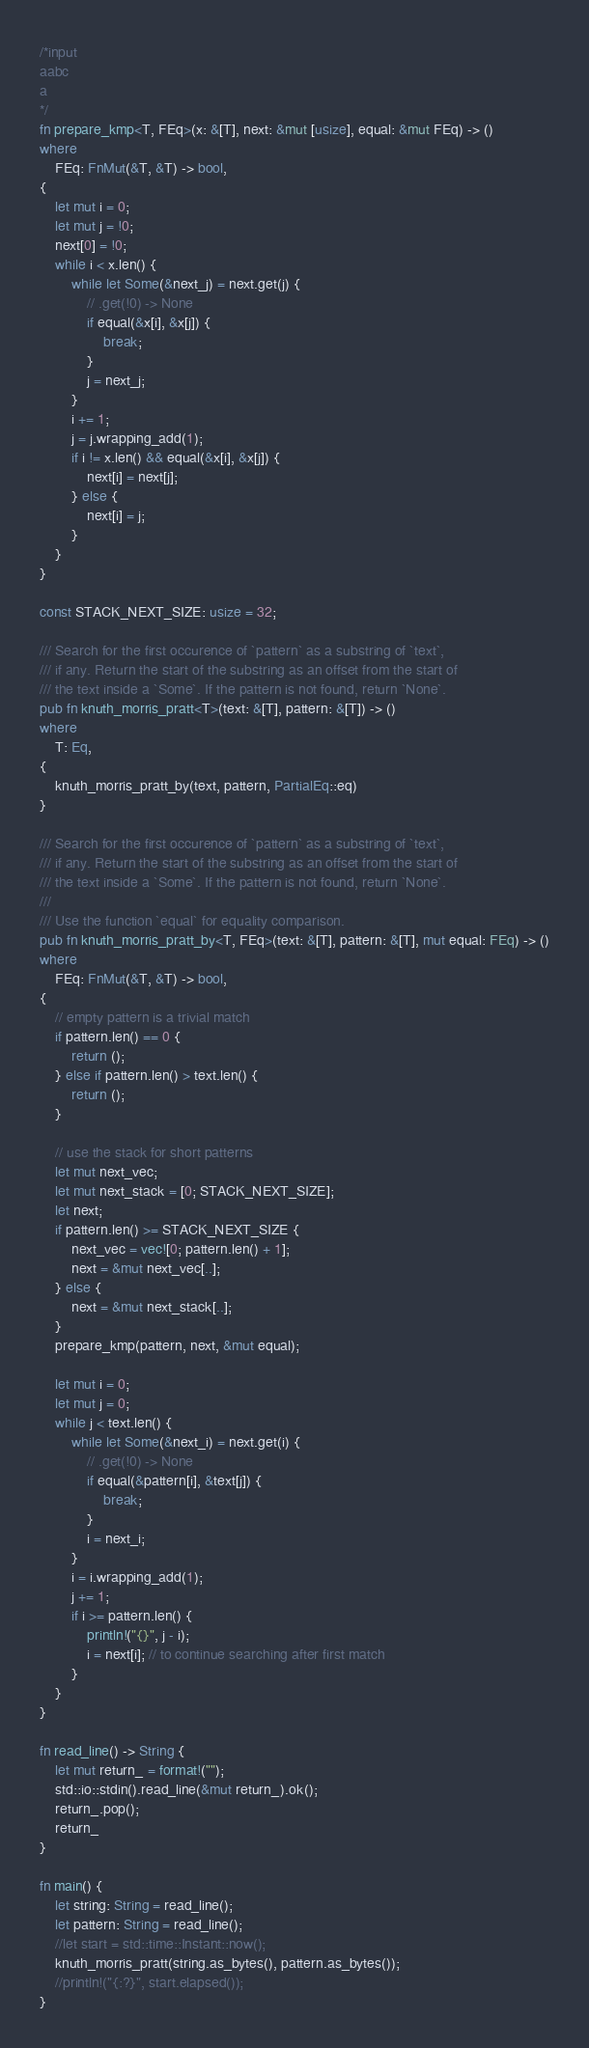Convert code to text. <code><loc_0><loc_0><loc_500><loc_500><_Rust_>/*input
aabc
a
*/
fn prepare_kmp<T, FEq>(x: &[T], next: &mut [usize], equal: &mut FEq) -> ()
where
    FEq: FnMut(&T, &T) -> bool,
{
    let mut i = 0;
    let mut j = !0;
    next[0] = !0;
    while i < x.len() {
        while let Some(&next_j) = next.get(j) {
            // .get(!0) -> None
            if equal(&x[i], &x[j]) {
                break;
            }
            j = next_j;
        }
        i += 1;
        j = j.wrapping_add(1);
        if i != x.len() && equal(&x[i], &x[j]) {
            next[i] = next[j];
        } else {
            next[i] = j;
        }
    }
}

const STACK_NEXT_SIZE: usize = 32;

/// Search for the first occurence of `pattern` as a substring of `text`,
/// if any. Return the start of the substring as an offset from the start of
/// the text inside a `Some`. If the pattern is not found, return `None`.
pub fn knuth_morris_pratt<T>(text: &[T], pattern: &[T]) -> ()
where
    T: Eq,
{
    knuth_morris_pratt_by(text, pattern, PartialEq::eq)
}

/// Search for the first occurence of `pattern` as a substring of `text`,
/// if any. Return the start of the substring as an offset from the start of
/// the text inside a `Some`. If the pattern is not found, return `None`.
///
/// Use the function `equal` for equality comparison.
pub fn knuth_morris_pratt_by<T, FEq>(text: &[T], pattern: &[T], mut equal: FEq) -> ()
where
    FEq: FnMut(&T, &T) -> bool,
{
    // empty pattern is a trivial match
    if pattern.len() == 0 {
        return ();
    } else if pattern.len() > text.len() {
        return ();
    }

    // use the stack for short patterns
    let mut next_vec;
    let mut next_stack = [0; STACK_NEXT_SIZE];
    let next;
    if pattern.len() >= STACK_NEXT_SIZE {
        next_vec = vec![0; pattern.len() + 1];
        next = &mut next_vec[..];
    } else {
        next = &mut next_stack[..];
    }
    prepare_kmp(pattern, next, &mut equal);

    let mut i = 0;
    let mut j = 0;
    while j < text.len() {
        while let Some(&next_i) = next.get(i) {
            // .get(!0) -> None
            if equal(&pattern[i], &text[j]) {
                break;
            }
            i = next_i;
        }
        i = i.wrapping_add(1);
        j += 1;
        if i >= pattern.len() {
            println!("{}", j - i);
            i = next[i]; // to continue searching after first match
        }
    }
}

fn read_line() -> String {
    let mut return_ = format!("");
    std::io::stdin().read_line(&mut return_).ok();
    return_.pop();
    return_
}

fn main() {
    let string: String = read_line();
    let pattern: String = read_line();
    //let start = std::time::Instant::now();
    knuth_morris_pratt(string.as_bytes(), pattern.as_bytes());
    //println!("{:?}", start.elapsed());
}

</code> 